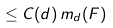<formula> <loc_0><loc_0><loc_500><loc_500>\leq C ( d ) \, m _ { d } ( F )</formula> 